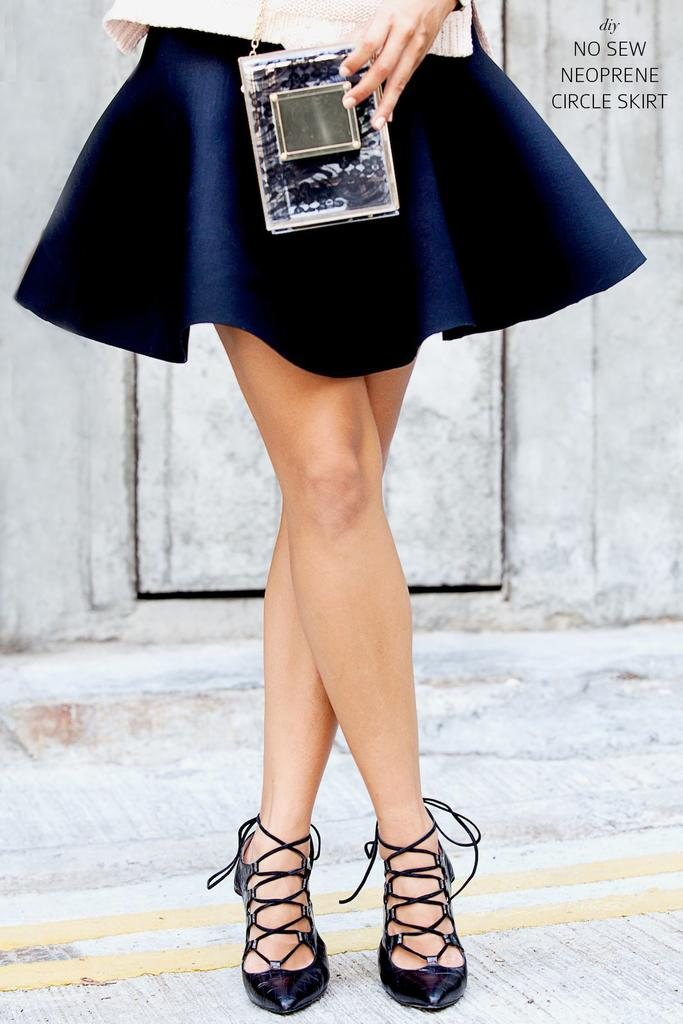What is the main subject in the image? There is a person standing in the image. Can you describe the background of the image? There is a wall behind the person. How many frogs are jumping on the person's head in the image? There are no frogs present in the image, so it is not possible to answer that question. 